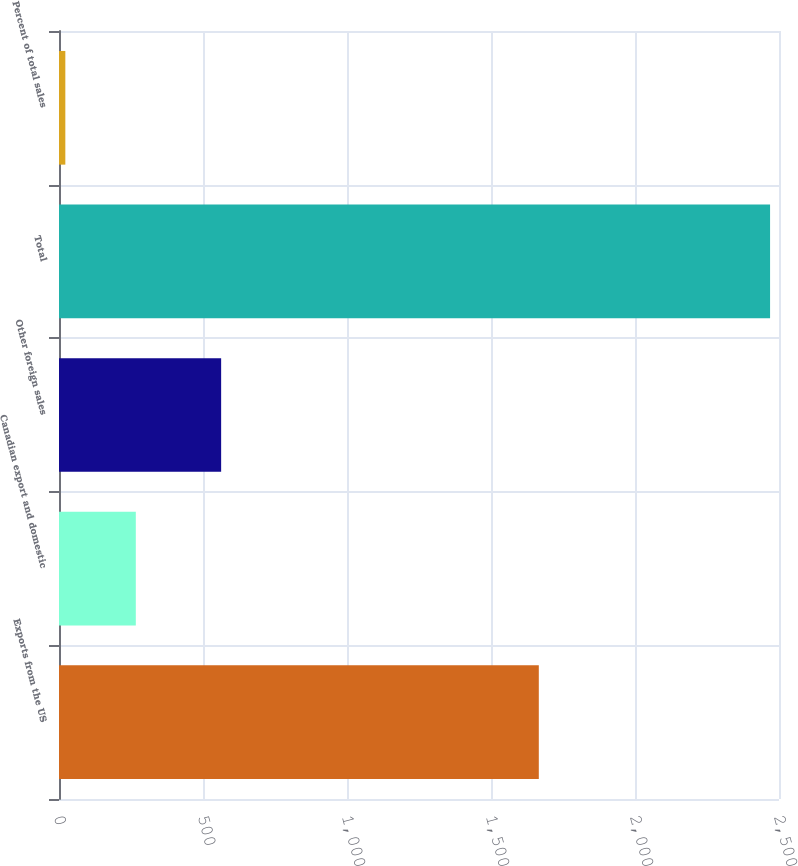Convert chart to OTSL. <chart><loc_0><loc_0><loc_500><loc_500><bar_chart><fcel>Exports from the US<fcel>Canadian export and domestic<fcel>Other foreign sales<fcel>Total<fcel>Percent of total sales<nl><fcel>1666<fcel>266.7<fcel>563<fcel>2469<fcel>22<nl></chart> 